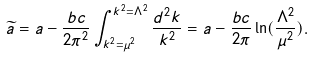Convert formula to latex. <formula><loc_0><loc_0><loc_500><loc_500>\widetilde { a } = a - \frac { b c } { 2 \pi ^ { 2 } } \int _ { k ^ { 2 } = \mu ^ { 2 } } ^ { k ^ { 2 } = \Lambda ^ { 2 } } \frac { d ^ { 2 } k } { k ^ { 2 } } = a - \frac { b c } { 2 \pi } \ln ( \frac { \Lambda ^ { 2 } } { \mu ^ { 2 } } ) .</formula> 